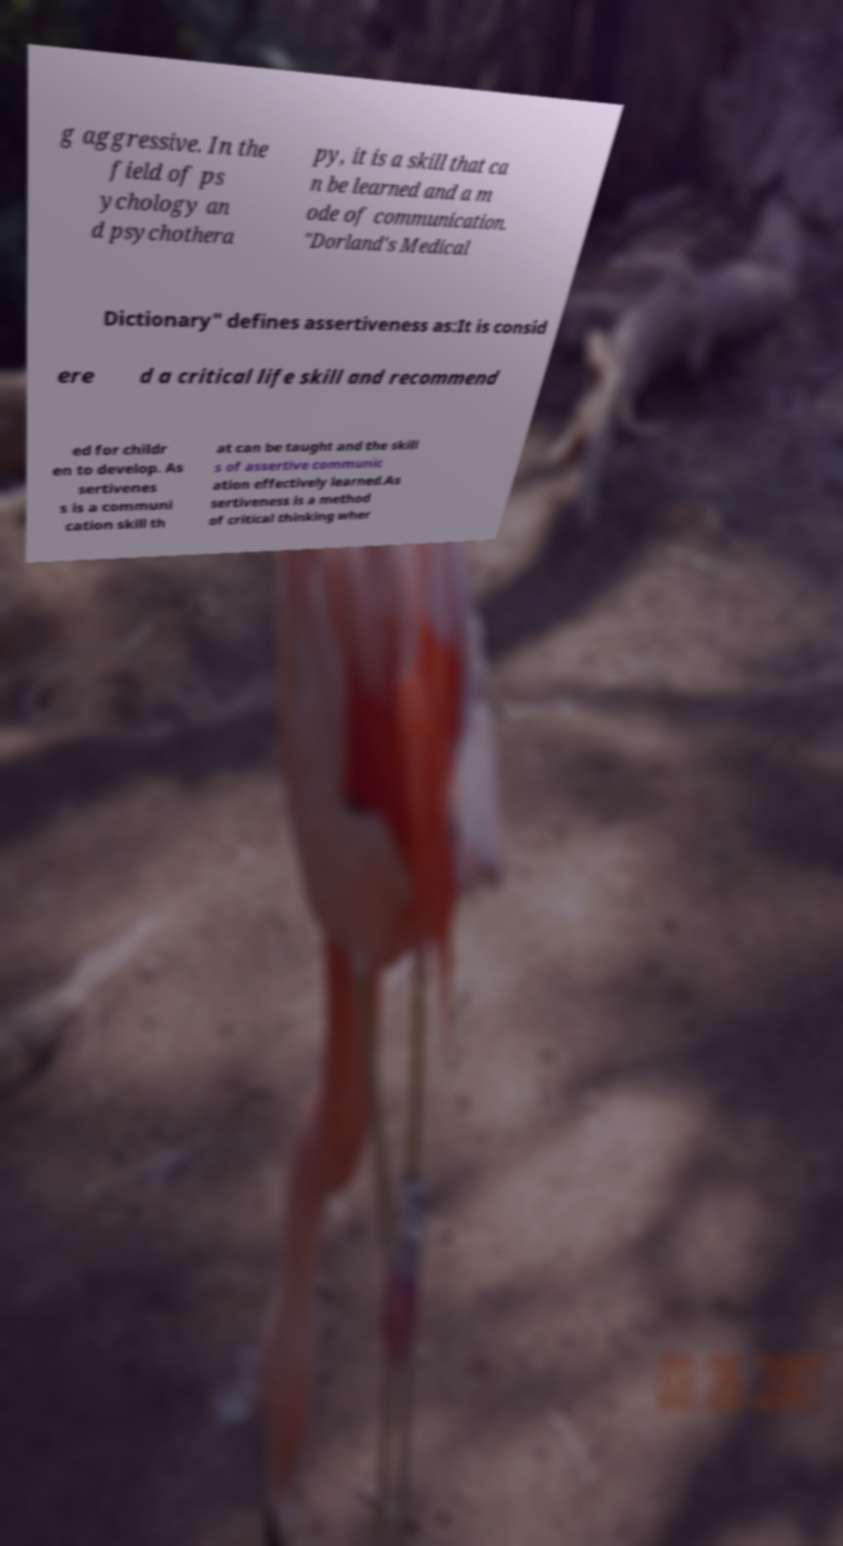I need the written content from this picture converted into text. Can you do that? g aggressive. In the field of ps ychology an d psychothera py, it is a skill that ca n be learned and a m ode of communication. "Dorland's Medical Dictionary" defines assertiveness as:It is consid ere d a critical life skill and recommend ed for childr en to develop. As sertivenes s is a communi cation skill th at can be taught and the skill s of assertive communic ation effectively learned.As sertiveness is a method of critical thinking wher 